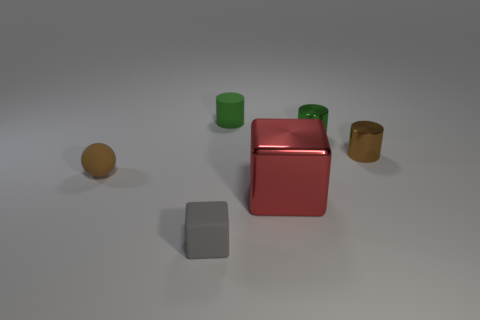What is the tiny brown object that is on the right side of the green rubber thing made of?
Make the answer very short. Metal. How many other objects are the same size as the green matte object?
Provide a succinct answer. 4. There is a brown rubber ball; does it have the same size as the metal object that is in front of the tiny brown matte sphere?
Ensure brevity in your answer.  No. What is the shape of the small matte object behind the brown object on the left side of the small object that is in front of the red metallic object?
Ensure brevity in your answer.  Cylinder. Are there fewer small gray blocks than tiny yellow blocks?
Your answer should be very brief. No. There is a small matte block; are there any gray blocks in front of it?
Offer a terse response. No. What is the shape of the rubber object that is both behind the large cube and to the right of the tiny brown rubber ball?
Ensure brevity in your answer.  Cylinder. Is there another rubber thing that has the same shape as the brown rubber thing?
Keep it short and to the point. No. Is the size of the brown thing that is behind the brown matte sphere the same as the cube in front of the large red cube?
Provide a short and direct response. Yes. Is the number of gray matte cubes greater than the number of blue matte objects?
Give a very brief answer. Yes. 